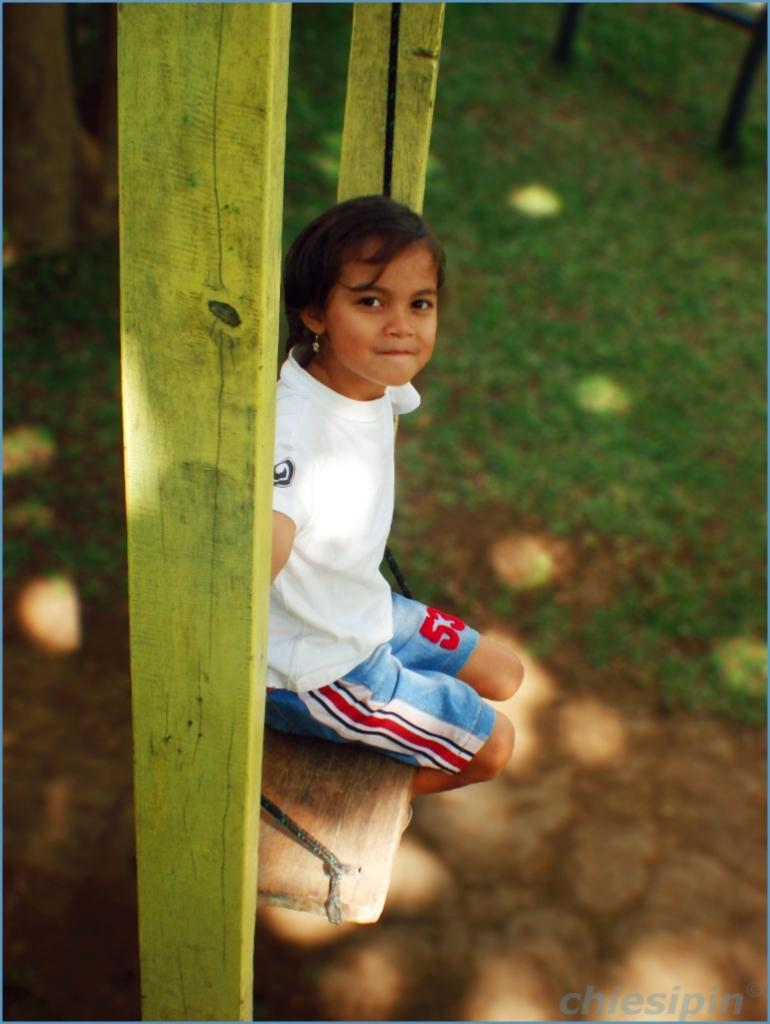<image>
Write a terse but informative summary of the picture. A young girl numbered 53 sits on a wooden swing. 